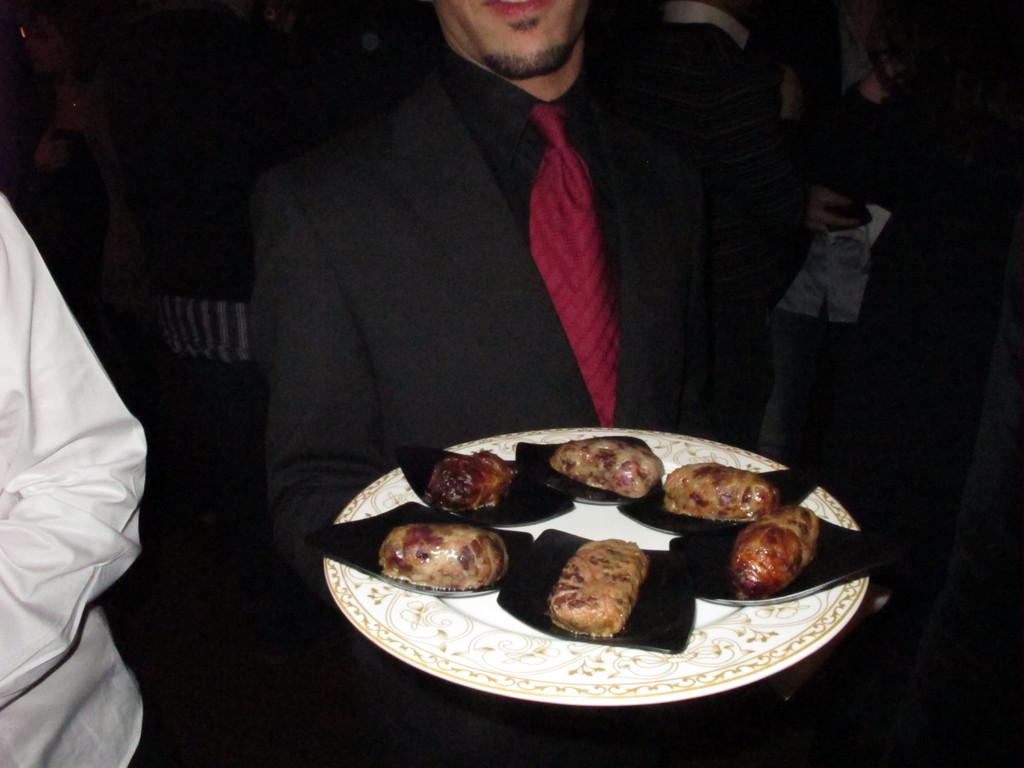How many people are in the image? There are people in the image, but the exact number is not specified. What is the person holding in the image? There is a person holding a plate in the image. What is on the plate that the person is holding? The plate contains food items. What type of whip can be seen in the image? There is no whip present in the image. How does the person holding the plate breathe while holding it? The person holding the plate is not shown to be having any difficulty breathing, and the image does not provide information about their breathing. 